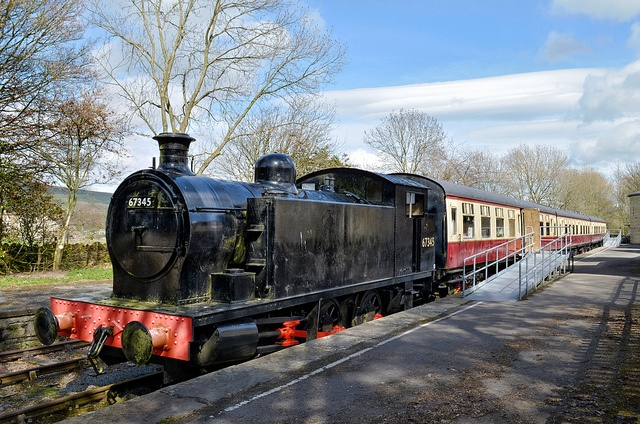Describe the objects in this image and their specific colors. I can see a train in lightblue, black, gray, darkgray, and darkgreen tones in this image. 